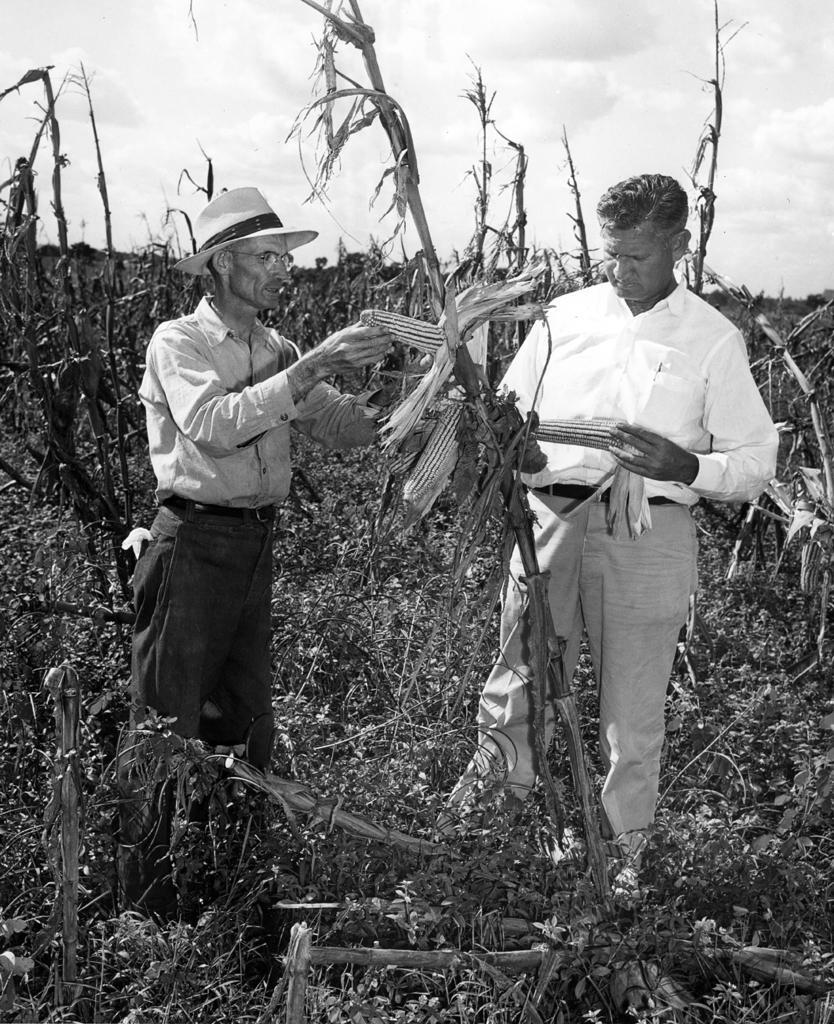Describe this image in one or two sentences. In this picture we can observe two men standing on the ground. There are some plants in the background. We can observe a person wearing a hat on his head. In the background there is a sky and some clouds. 